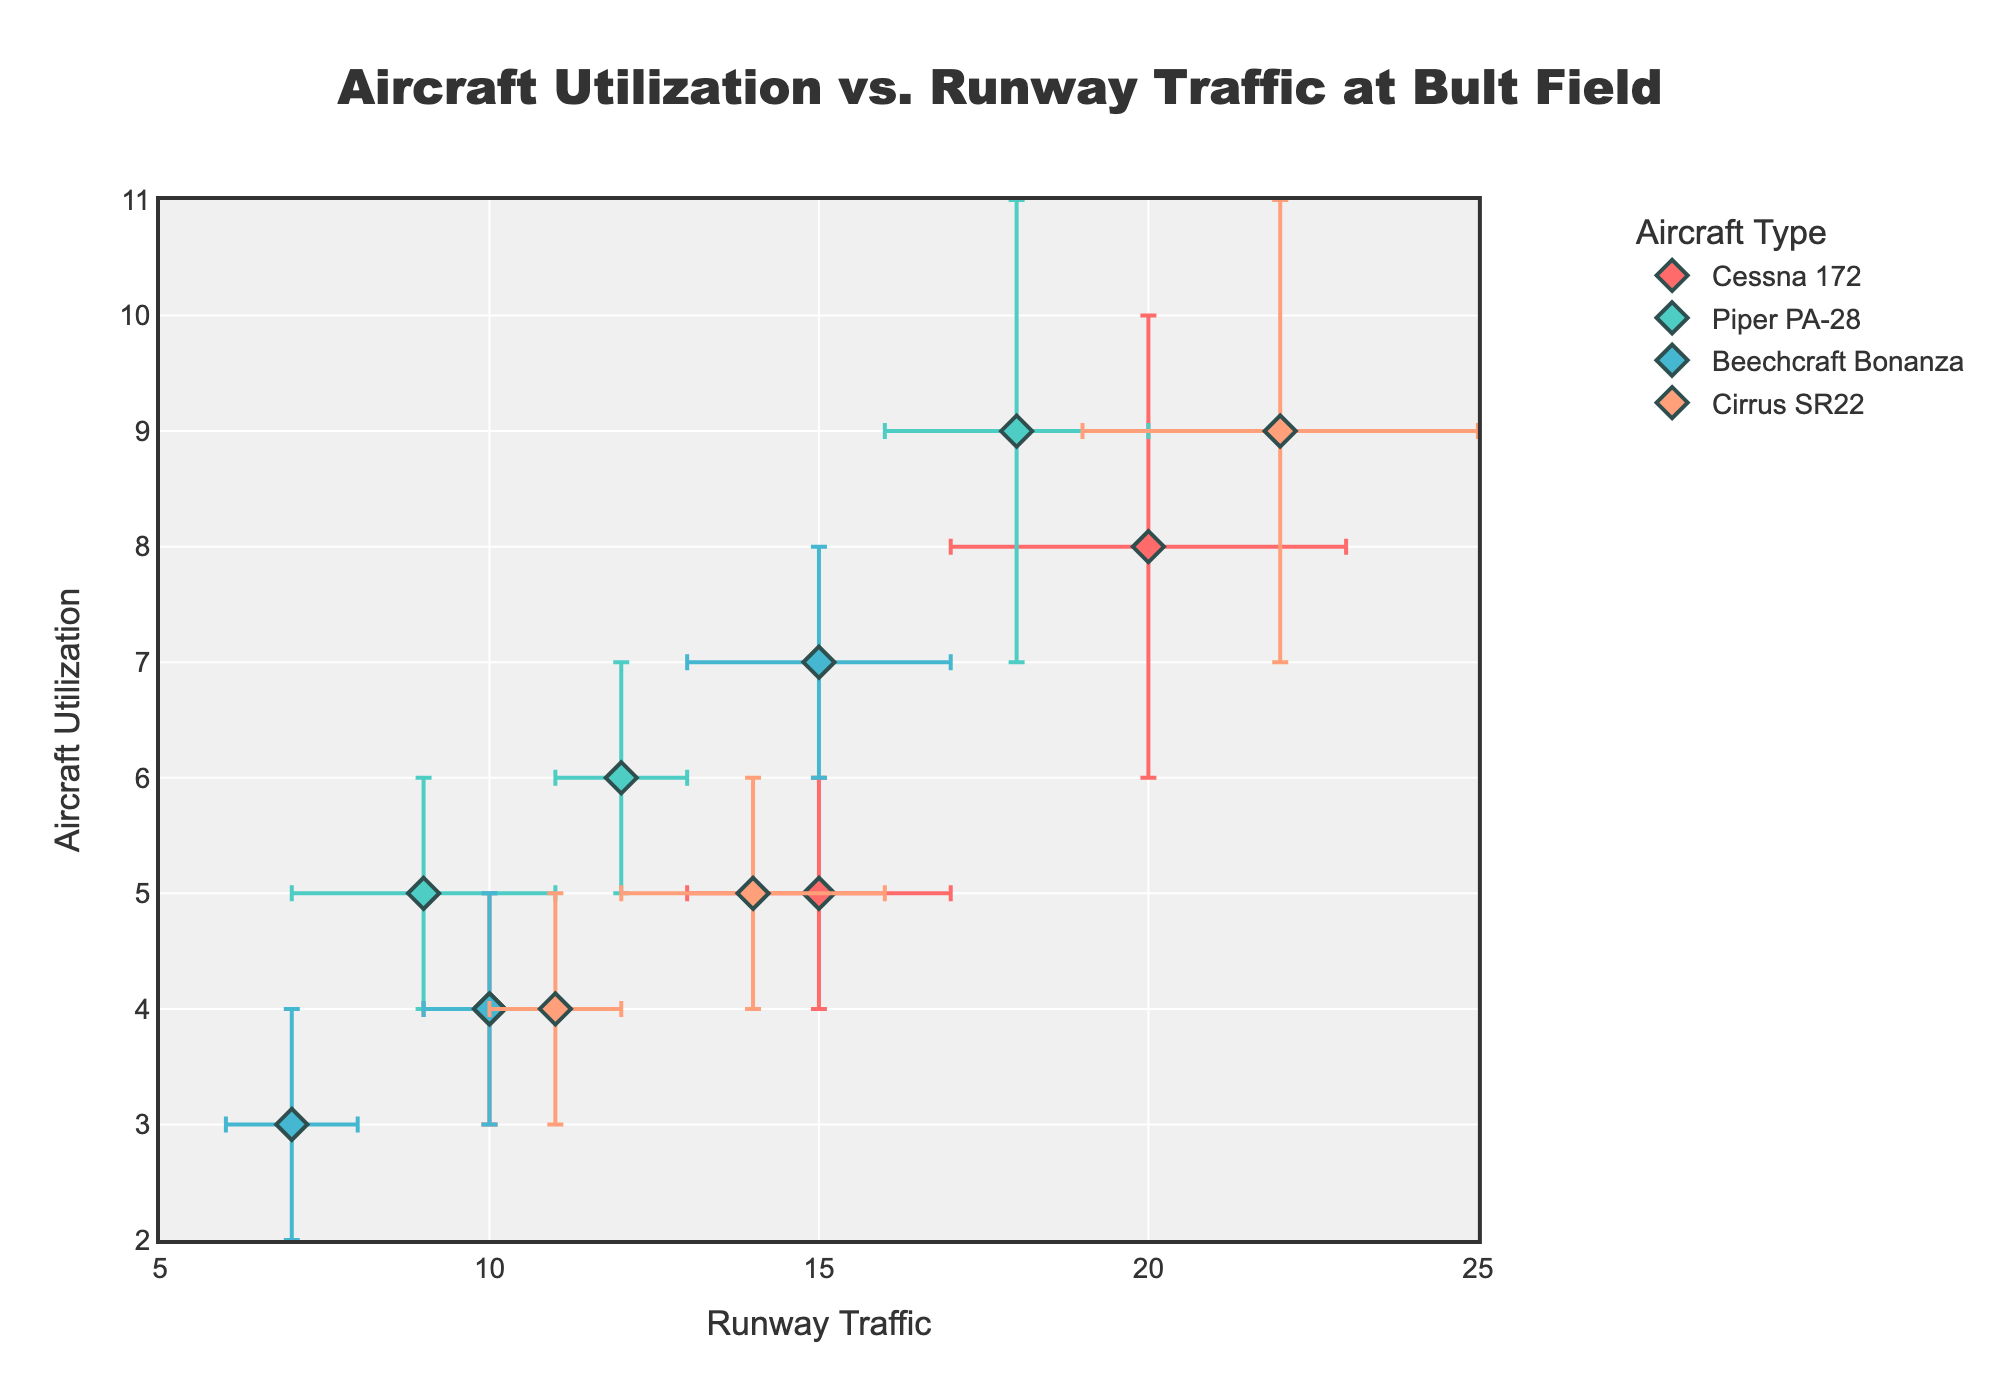What is the title of the figure? The title of the figure is usually located at the top and describes the topic or data trend being presented. In this case, it reads 'Aircraft Utilization vs. Runway Traffic at Bult Field'.
Answer: Aircraft Utilization vs. Runway Traffic at Bult Field How many aircraft types are displayed in the figure? To determine the number of different aircraft types, one should count the unique categories in the legend or the scatter plot markers. There are four aircraft types: Cessna 172, Piper PA-28, Beechcraft Bonanza, and Cirrus SR22.
Answer: Four Which aircraft has the highest aircraft utilization in the afternoon? By examining the markers for each aircraft type at the afternoon time period and comparing their y-axis values, Cirrus SR22 reaches the highest utilization at 9 units.
Answer: Cirrus SR22 Which time of day shows the lowest runway traffic for the Piper PA-28? To identify this, locate the data points for Piper PA-28 and find the one with the smallest x-axis value, which represents runway traffic. The evening period has the lowest runway traffic for Piper PA-28 at 9.
Answer: Evening What's the range of runway traffic values depicted in the plot? Observe the x-axis to find the minimum and maximum values depicted for runway traffic. The range is from 5 to 25.
Answer: 5 to 25 Which aircraft has the most consistent aircraft utilization across different times of day? Examine the error bars along the y-axis to see which aircraft type has the smallest variance, indicating consistency. The Beechcraft Bonanza shows the least change in aircraft utilization values.
Answer: Beechcraft Bonanza What's the average runway traffic for the Cessna 172 across all times of day? Add up the runway traffic values for the Cessna 172 at Morning (15), Afternoon (20), and Evening (10), and then divide by 3. (15+20+10)/3 = 45/3 = 15.
Answer: 15 Between the Piper PA-28 and Cirrus SR22, which aircraft shows more variability in runway traffic in the afternoon? Compare the size of the error bars for both aircraft in the afternoon period along the x-axis. Cirrus SR22 has larger error bars, indicating more variability in runway traffic.
Answer: Cirrus SR22 For which aircraft and time of day, does the highest observed runway traffic occur, and what is its value? Look at the scatter plot to find the highest x-axis value and note the corresponding aircraft and time of day. The Cirrus SR22 in the afternoon has the highest runway traffic of 22.
Answer: Cirrus SR22, Afternoon Compare the morning and evening aircraft utilization for the Beechcraft Bonanza and determine the difference. Find the y-axis values for Beechcraft Bonanza in the morning (4) and evening (3), and subtract the evening value from the morning value. 4 - 3 = 1.
Answer: 1 